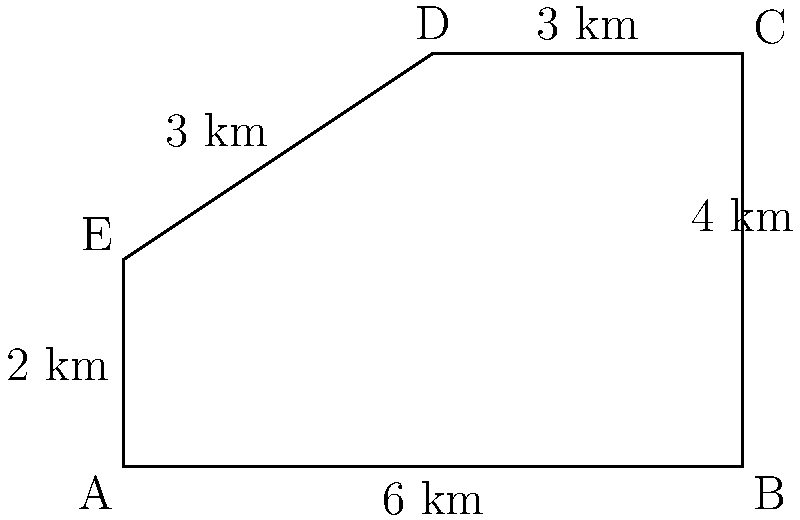A classified military base has an irregular pentagonal shape as shown in the diagram. Calculate the total area of the base in square kilometers. To calculate the area of the irregular pentagon, we can divide it into simpler shapes:

1. Rectangle ABCD':
   Width = 6 km
   Height = 2 km
   Area of rectangle = $6 \times 2 = 12$ sq km

2. Right triangle CC'D:
   Base = 3 km
   Height = 2 km
   Area of triangle = $\frac{1}{2} \times 3 \times 2 = 3$ sq km

3. Right triangle AEE':
   Base = 3 km
   Height = 2 km
   Area of triangle = $\frac{1}{2} \times 3 \times 2 = 3$ sq km

Total area:
$$\text{Total Area} = 12 + 3 + 3 = 18 \text{ sq km}$$
Answer: 18 sq km 